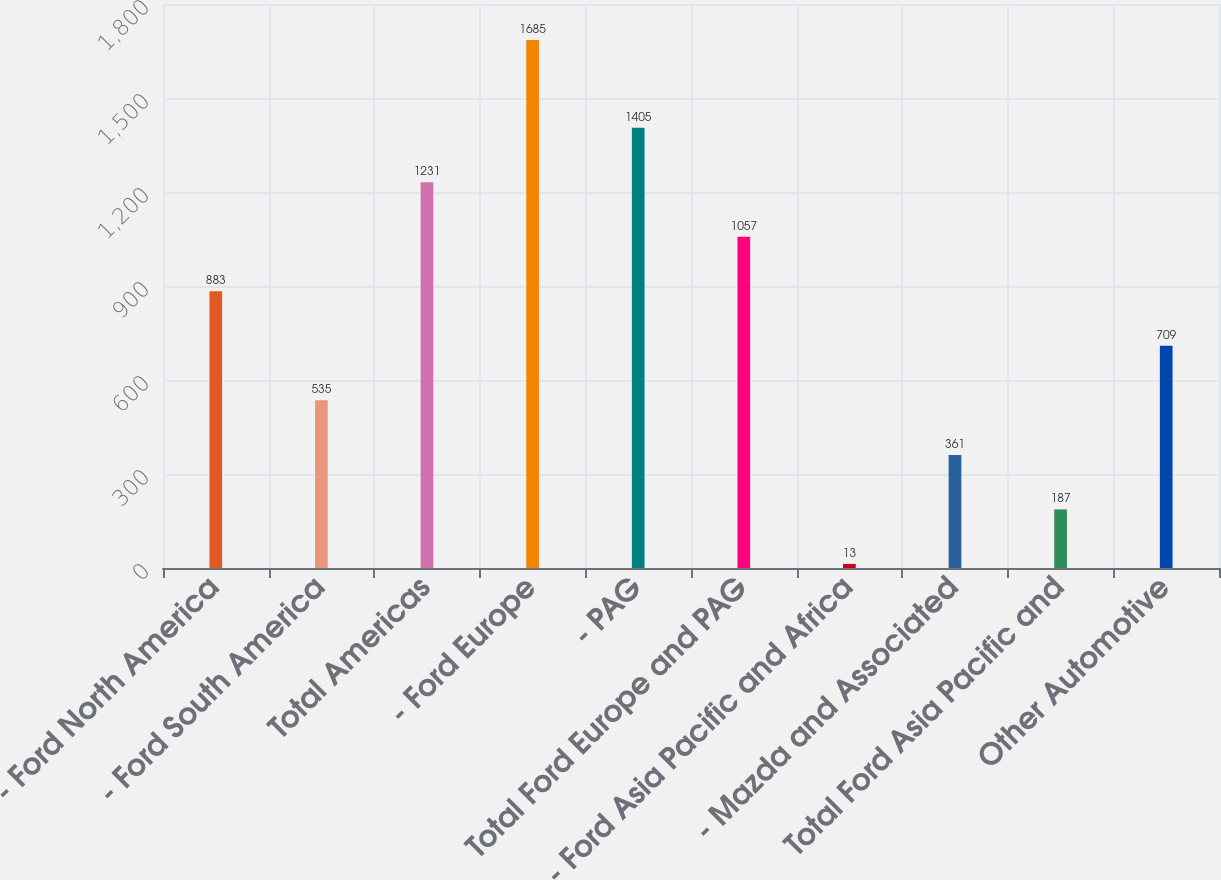<chart> <loc_0><loc_0><loc_500><loc_500><bar_chart><fcel>- Ford North America<fcel>- Ford South America<fcel>Total Americas<fcel>- Ford Europe<fcel>- PAG<fcel>Total Ford Europe and PAG<fcel>- Ford Asia Pacific and Africa<fcel>- Mazda and Associated<fcel>Total Ford Asia Pacific and<fcel>Other Automotive<nl><fcel>883<fcel>535<fcel>1231<fcel>1685<fcel>1405<fcel>1057<fcel>13<fcel>361<fcel>187<fcel>709<nl></chart> 